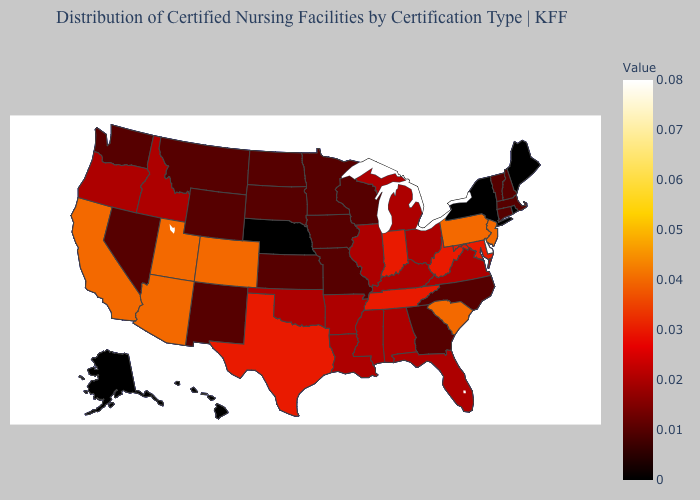Does Alaska have the lowest value in the USA?
Answer briefly. Yes. Among the states that border Oregon , which have the highest value?
Give a very brief answer. California. Which states have the lowest value in the MidWest?
Concise answer only. Nebraska. Among the states that border Pennsylvania , which have the lowest value?
Be succinct. New York. Which states hav the highest value in the MidWest?
Be succinct. Indiana. Does the map have missing data?
Keep it brief. No. Among the states that border Colorado , which have the highest value?
Keep it brief. Arizona, Utah. 